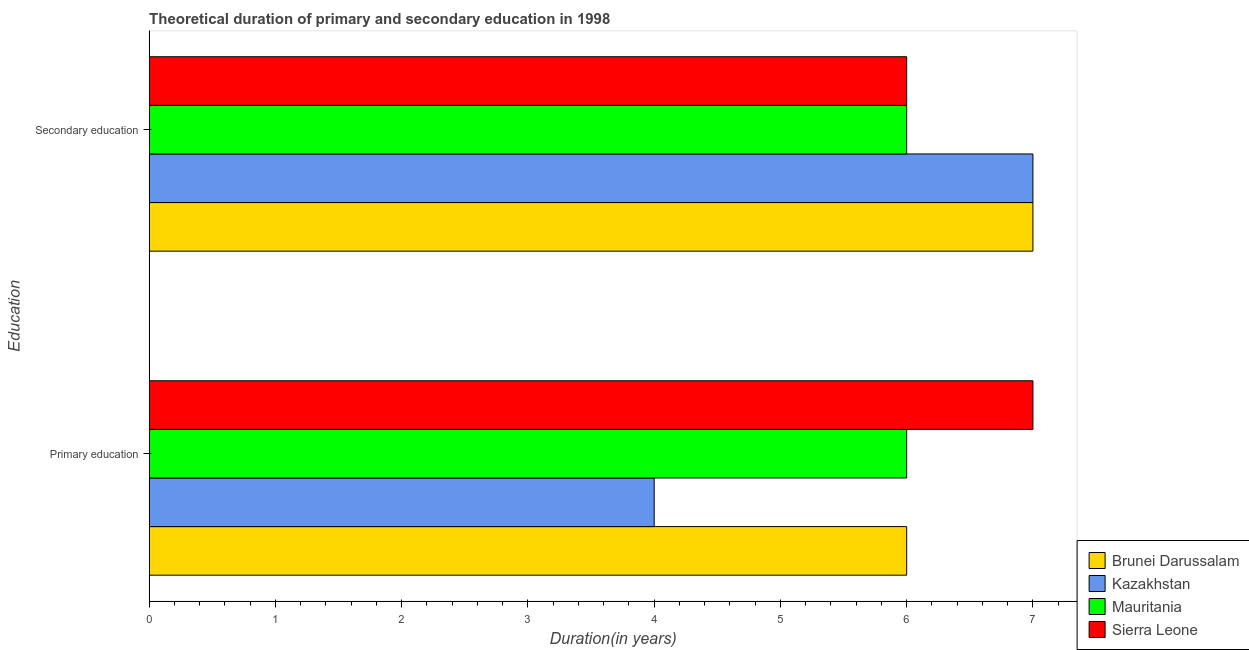How many groups of bars are there?
Give a very brief answer. 2. Are the number of bars on each tick of the Y-axis equal?
Your answer should be very brief. Yes. How many bars are there on the 1st tick from the top?
Give a very brief answer. 4. How many bars are there on the 1st tick from the bottom?
Provide a succinct answer. 4. What is the duration of primary education in Mauritania?
Give a very brief answer. 6. Across all countries, what is the maximum duration of secondary education?
Your answer should be compact. 7. Across all countries, what is the minimum duration of secondary education?
Make the answer very short. 6. In which country was the duration of primary education maximum?
Your answer should be compact. Sierra Leone. In which country was the duration of secondary education minimum?
Your answer should be very brief. Mauritania. What is the total duration of primary education in the graph?
Give a very brief answer. 23. What is the difference between the duration of primary education in Kazakhstan and that in Sierra Leone?
Your answer should be compact. -3. What is the difference between the duration of secondary education in Brunei Darussalam and the duration of primary education in Mauritania?
Keep it short and to the point. 1. What is the average duration of primary education per country?
Provide a short and direct response. 5.75. What is the difference between the duration of primary education and duration of secondary education in Kazakhstan?
Provide a short and direct response. -3. What is the ratio of the duration of primary education in Kazakhstan to that in Mauritania?
Offer a terse response. 0.67. Is the duration of secondary education in Kazakhstan less than that in Brunei Darussalam?
Your answer should be very brief. No. What does the 1st bar from the top in Secondary education represents?
Ensure brevity in your answer.  Sierra Leone. What does the 2nd bar from the bottom in Primary education represents?
Your answer should be very brief. Kazakhstan. Are all the bars in the graph horizontal?
Ensure brevity in your answer.  Yes. What is the difference between two consecutive major ticks on the X-axis?
Offer a terse response. 1. Does the graph contain any zero values?
Give a very brief answer. No. Where does the legend appear in the graph?
Ensure brevity in your answer.  Bottom right. How are the legend labels stacked?
Your answer should be very brief. Vertical. What is the title of the graph?
Offer a very short reply. Theoretical duration of primary and secondary education in 1998. What is the label or title of the X-axis?
Your answer should be compact. Duration(in years). What is the label or title of the Y-axis?
Your answer should be compact. Education. What is the Duration(in years) of Kazakhstan in Primary education?
Give a very brief answer. 4. What is the Duration(in years) of Kazakhstan in Secondary education?
Your answer should be compact. 7. What is the Duration(in years) in Sierra Leone in Secondary education?
Ensure brevity in your answer.  6. Across all Education, what is the maximum Duration(in years) of Sierra Leone?
Keep it short and to the point. 7. Across all Education, what is the minimum Duration(in years) in Brunei Darussalam?
Make the answer very short. 6. Across all Education, what is the minimum Duration(in years) of Kazakhstan?
Provide a short and direct response. 4. Across all Education, what is the minimum Duration(in years) of Mauritania?
Ensure brevity in your answer.  6. What is the total Duration(in years) of Mauritania in the graph?
Your response must be concise. 12. What is the difference between the Duration(in years) of Kazakhstan in Primary education and that in Secondary education?
Keep it short and to the point. -3. What is the difference between the Duration(in years) in Mauritania in Primary education and that in Secondary education?
Ensure brevity in your answer.  0. What is the difference between the Duration(in years) in Kazakhstan in Primary education and the Duration(in years) in Mauritania in Secondary education?
Give a very brief answer. -2. What is the difference between the Duration(in years) in Mauritania in Primary education and the Duration(in years) in Sierra Leone in Secondary education?
Offer a very short reply. 0. What is the average Duration(in years) in Brunei Darussalam per Education?
Offer a very short reply. 6.5. What is the difference between the Duration(in years) in Brunei Darussalam and Duration(in years) in Mauritania in Primary education?
Offer a very short reply. 0. What is the difference between the Duration(in years) of Mauritania and Duration(in years) of Sierra Leone in Primary education?
Give a very brief answer. -1. What is the difference between the Duration(in years) of Brunei Darussalam and Duration(in years) of Mauritania in Secondary education?
Provide a succinct answer. 1. What is the difference between the Duration(in years) of Kazakhstan and Duration(in years) of Mauritania in Secondary education?
Offer a terse response. 1. What is the difference between the Duration(in years) of Kazakhstan and Duration(in years) of Sierra Leone in Secondary education?
Offer a terse response. 1. What is the ratio of the Duration(in years) in Brunei Darussalam in Primary education to that in Secondary education?
Give a very brief answer. 0.86. What is the ratio of the Duration(in years) of Kazakhstan in Primary education to that in Secondary education?
Provide a succinct answer. 0.57. What is the difference between the highest and the second highest Duration(in years) of Kazakhstan?
Your response must be concise. 3. What is the difference between the highest and the lowest Duration(in years) in Brunei Darussalam?
Provide a short and direct response. 1. What is the difference between the highest and the lowest Duration(in years) in Kazakhstan?
Your response must be concise. 3. What is the difference between the highest and the lowest Duration(in years) in Mauritania?
Your answer should be compact. 0. What is the difference between the highest and the lowest Duration(in years) of Sierra Leone?
Offer a very short reply. 1. 